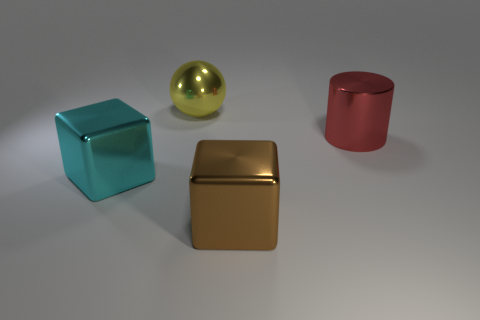How would you explain the lighting in the scene? The lighting in the scene appears to be diffused, likely from an overhead source, casting soft shadows beneath the objects. This type of lighting creates a calm atmosphere and allows the materials' reflective properties to stand out, as seen on the gold sphere and cube. 